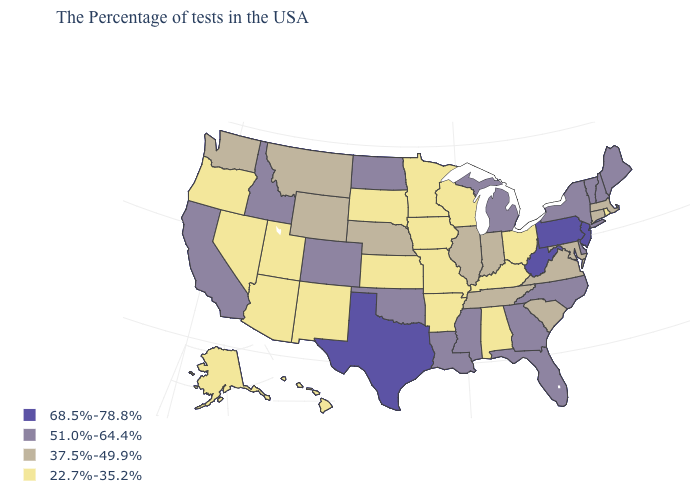Name the states that have a value in the range 22.7%-35.2%?
Short answer required. Rhode Island, Ohio, Kentucky, Alabama, Wisconsin, Missouri, Arkansas, Minnesota, Iowa, Kansas, South Dakota, New Mexico, Utah, Arizona, Nevada, Oregon, Alaska, Hawaii. What is the value of Texas?
Be succinct. 68.5%-78.8%. Name the states that have a value in the range 22.7%-35.2%?
Write a very short answer. Rhode Island, Ohio, Kentucky, Alabama, Wisconsin, Missouri, Arkansas, Minnesota, Iowa, Kansas, South Dakota, New Mexico, Utah, Arizona, Nevada, Oregon, Alaska, Hawaii. What is the value of Colorado?
Give a very brief answer. 51.0%-64.4%. What is the value of South Dakota?
Give a very brief answer. 22.7%-35.2%. Which states have the highest value in the USA?
Answer briefly. New Jersey, Pennsylvania, West Virginia, Texas. Does Ohio have the highest value in the USA?
Short answer required. No. Name the states that have a value in the range 22.7%-35.2%?
Be succinct. Rhode Island, Ohio, Kentucky, Alabama, Wisconsin, Missouri, Arkansas, Minnesota, Iowa, Kansas, South Dakota, New Mexico, Utah, Arizona, Nevada, Oregon, Alaska, Hawaii. What is the value of Texas?
Keep it brief. 68.5%-78.8%. Among the states that border Vermont , does Massachusetts have the highest value?
Short answer required. No. Name the states that have a value in the range 37.5%-49.9%?
Answer briefly. Massachusetts, Connecticut, Maryland, Virginia, South Carolina, Indiana, Tennessee, Illinois, Nebraska, Wyoming, Montana, Washington. What is the lowest value in the USA?
Write a very short answer. 22.7%-35.2%. Is the legend a continuous bar?
Short answer required. No. Does the first symbol in the legend represent the smallest category?
Write a very short answer. No. Name the states that have a value in the range 68.5%-78.8%?
Write a very short answer. New Jersey, Pennsylvania, West Virginia, Texas. 